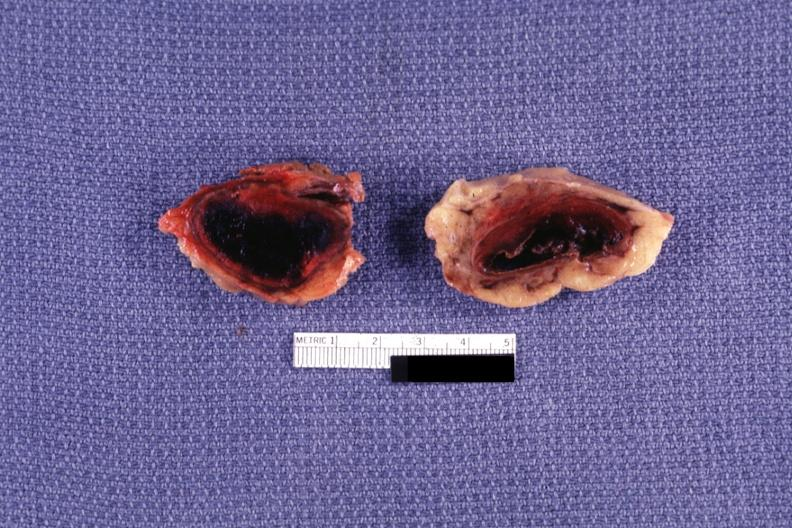how does this image show sectioned glands?
Answer the question using a single word or phrase. With obvious hemorrhage 